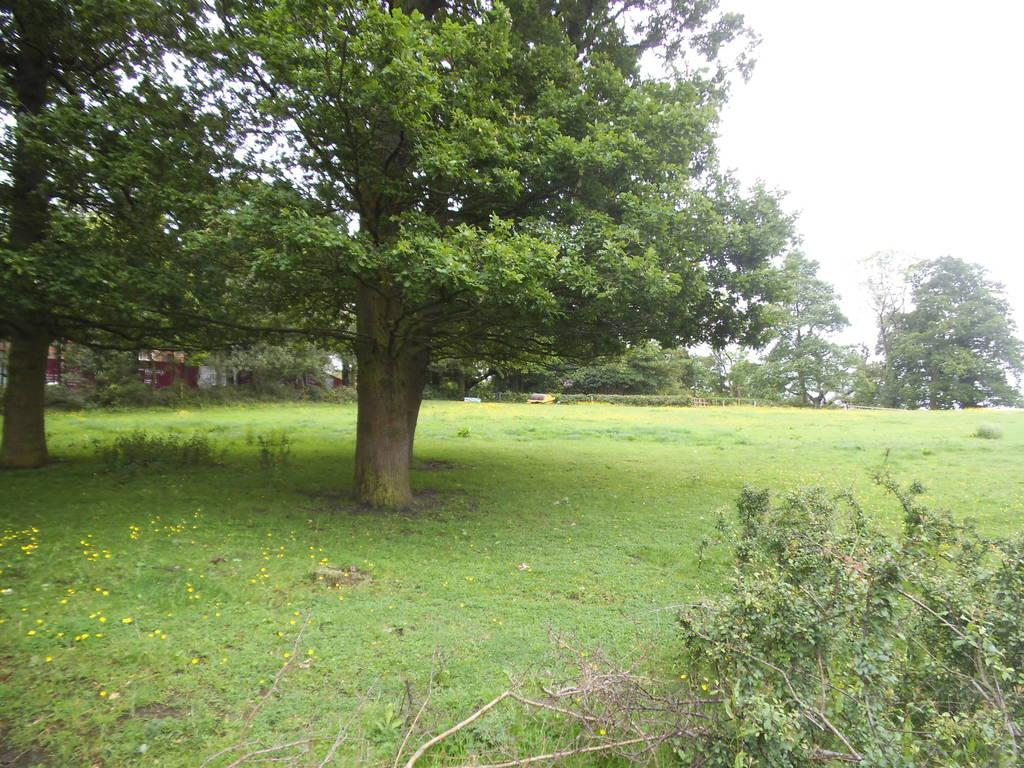What type of vegetation is in the foreground of the image? There are plants and grassland in the foreground of the image. What can be seen in the background of the image? There are trees, houses, and the sky visible in the background of the image. What type of current can be seen flowing through the grassland in the image? There is no current visible in the image; it is a still image of plants, grassland, trees, houses, and the sky. Can you see any worms crawling on the plants in the image? There are no worms visible in the image; it only shows plants, grassland, trees, houses, and the sky. 